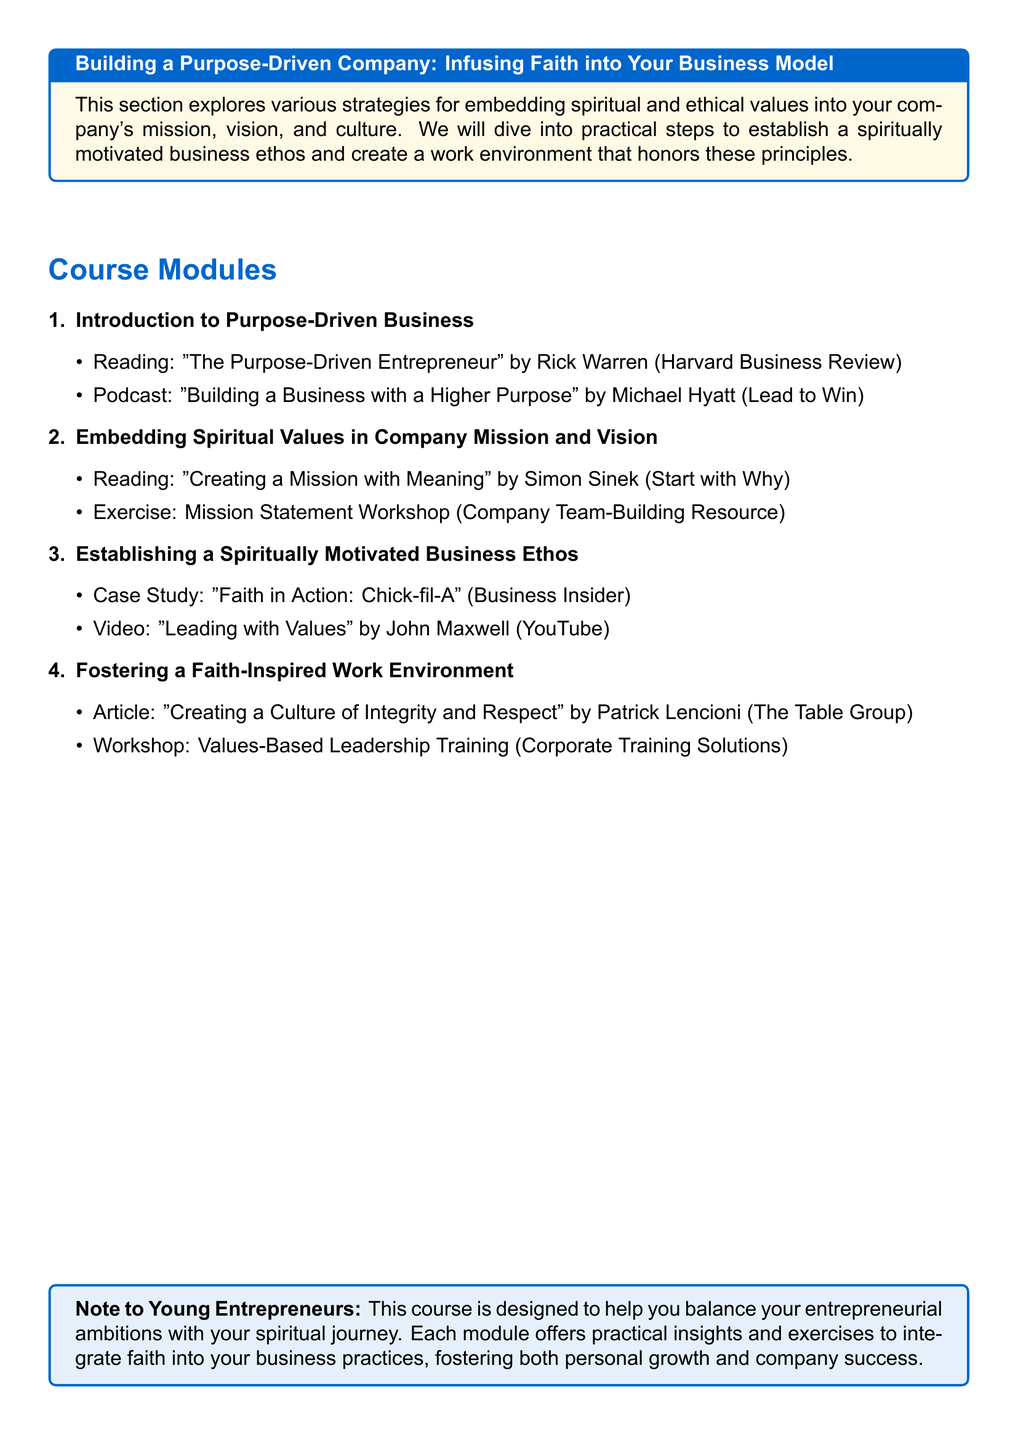What is the title of the course? The title is specifically mentioned at the top of the syllabus, indicating the focus on building a purpose-driven company infused with faith.
Answer: Building a Purpose-Driven Company: Infusing Faith into Your Business Model Who is the author of "The Purpose-Driven Entrepreneur"? The author of this reading listed in the introduction module is mentioned within the course material section.
Answer: Rick Warren What is the name of the podcast featured in the first module? The syllabus lists a podcast title in the first module, which serves as an educational resource.
Answer: Building a Business with a Higher Purpose Which company is highlighted in the case study? The syllabus includes a case study that illustrates a successful example of a purpose-driven business, which can be found in the relevant module.
Answer: Chick-fil-A What type of training does the values-based leadership workshop provide? The syllabus describes a specific workshop that aims to improve leadership aligned with faith-based values.
Answer: Values-Based Leadership Training How many course modules are there? The syllabus presents a clear listing of segments or topics covered in the course, which can be summed easily.
Answer: Four What is the purpose of the "Mission Statement Workshop"? The syllabus outlines specific activities intended to help participants develop critical elements of company ethos.
Answer: Team-Building Resource Who authored the article on creating a culture of integrity and respect? The author of a specified article focused on workplace culture is outlined in the course material.
Answer: Patrick Lencioni 